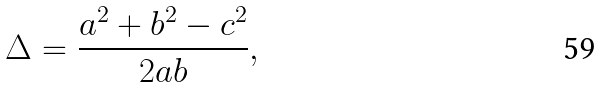Convert formula to latex. <formula><loc_0><loc_0><loc_500><loc_500>\Delta = \frac { a ^ { 2 } + b ^ { 2 } - c ^ { 2 } } { 2 a b } ,</formula> 